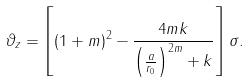<formula> <loc_0><loc_0><loc_500><loc_500>\vartheta _ { z } = \left [ ( 1 + m ) ^ { 2 } - \frac { 4 m k } { \left ( \frac { a } { r _ { 0 } } \right ) ^ { 2 m } + k } \right ] \sigma .</formula> 